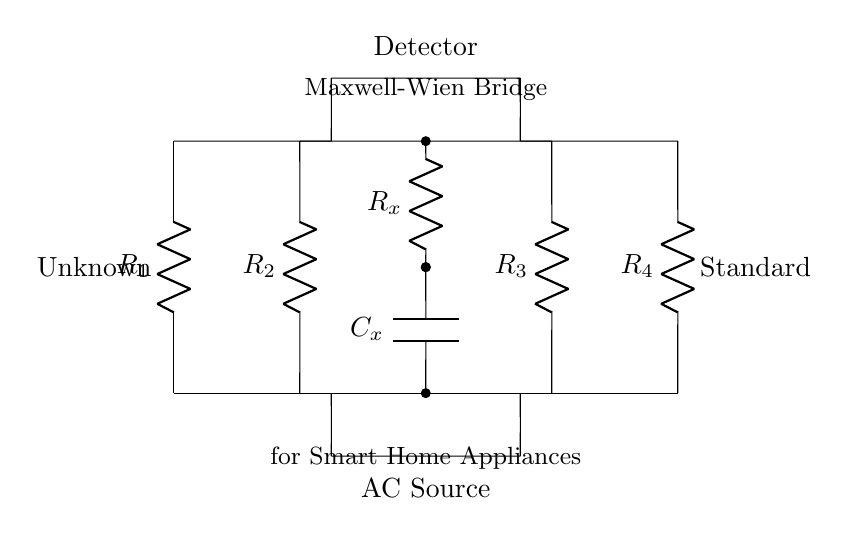What type of bridge is shown in the circuit? The circuit is a Maxwell-Wien Bridge, as indicated by the label on the diagram. This type of bridge is used specifically for calculating capacitance and dissipation factors.
Answer: Maxwell-Wien Bridge What component is connected to the AC source? The AC source is connected at the bottom of the circuit diagram, labeled as "AC Source" and connected to the resistors.
Answer: AC Source How many resistors are present in the circuit? The diagram shows four resistors labeled R1, R2, R3, and R4.
Answer: 4 What does C_x represent in the circuit? C_x represents the unknown capacitance that the bridge is designed to measure. It is positioned prominently in the center of the circuit.
Answer: Unknown Capacitance Which component is connected to the detector? The detector is connected to the junction between the resistors and the capacitor, as indicated in the diagram.
Answer: Detector What is the purpose of the Maxwell-Wien Bridge in smart home appliances? The purpose is to determine the capacitance and dissipation factor of capacitors in smart home appliances. The setup allows for precision measurements of capacitive components.
Answer: Measure capacitance and dissipation factor In what position is the standard component located? The standard component is placed on the right side of the bridge. This reflects the reference used for comparison against the unknown component C_x.
Answer: Right side 